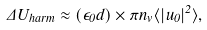Convert formula to latex. <formula><loc_0><loc_0><loc_500><loc_500>\Delta U _ { h a r m } \approx ( \epsilon _ { 0 } d ) \times \pi n _ { v } \langle | { u } _ { 0 } | ^ { 2 } \rangle ,</formula> 